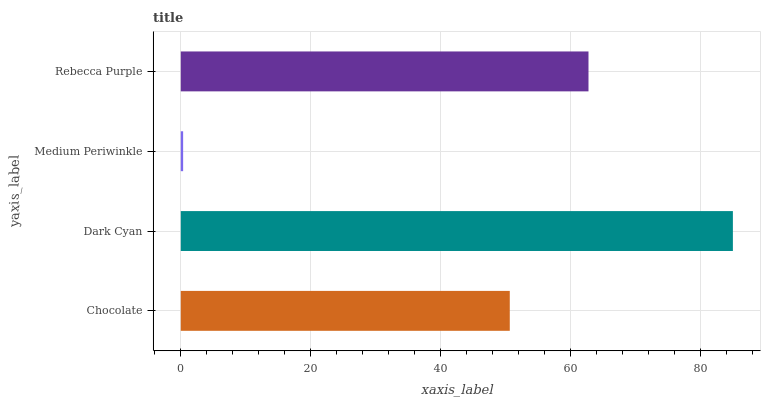Is Medium Periwinkle the minimum?
Answer yes or no. Yes. Is Dark Cyan the maximum?
Answer yes or no. Yes. Is Dark Cyan the minimum?
Answer yes or no. No. Is Medium Periwinkle the maximum?
Answer yes or no. No. Is Dark Cyan greater than Medium Periwinkle?
Answer yes or no. Yes. Is Medium Periwinkle less than Dark Cyan?
Answer yes or no. Yes. Is Medium Periwinkle greater than Dark Cyan?
Answer yes or no. No. Is Dark Cyan less than Medium Periwinkle?
Answer yes or no. No. Is Rebecca Purple the high median?
Answer yes or no. Yes. Is Chocolate the low median?
Answer yes or no. Yes. Is Medium Periwinkle the high median?
Answer yes or no. No. Is Dark Cyan the low median?
Answer yes or no. No. 